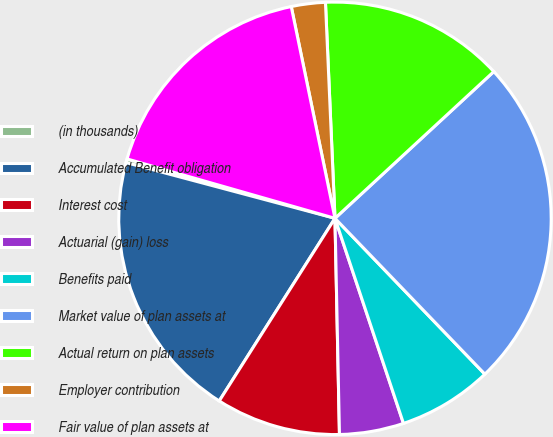<chart> <loc_0><loc_0><loc_500><loc_500><pie_chart><fcel>(in thousands)<fcel>Accumulated Benefit obligation<fcel>Interest cost<fcel>Actuarial (gain) loss<fcel>Benefits paid<fcel>Market value of plan assets at<fcel>Actual return on plan assets<fcel>Employer contribution<fcel>Fair value of plan assets at<nl><fcel>0.28%<fcel>20.16%<fcel>9.32%<fcel>4.8%<fcel>7.06%<fcel>24.68%<fcel>13.83%<fcel>2.54%<fcel>17.33%<nl></chart> 